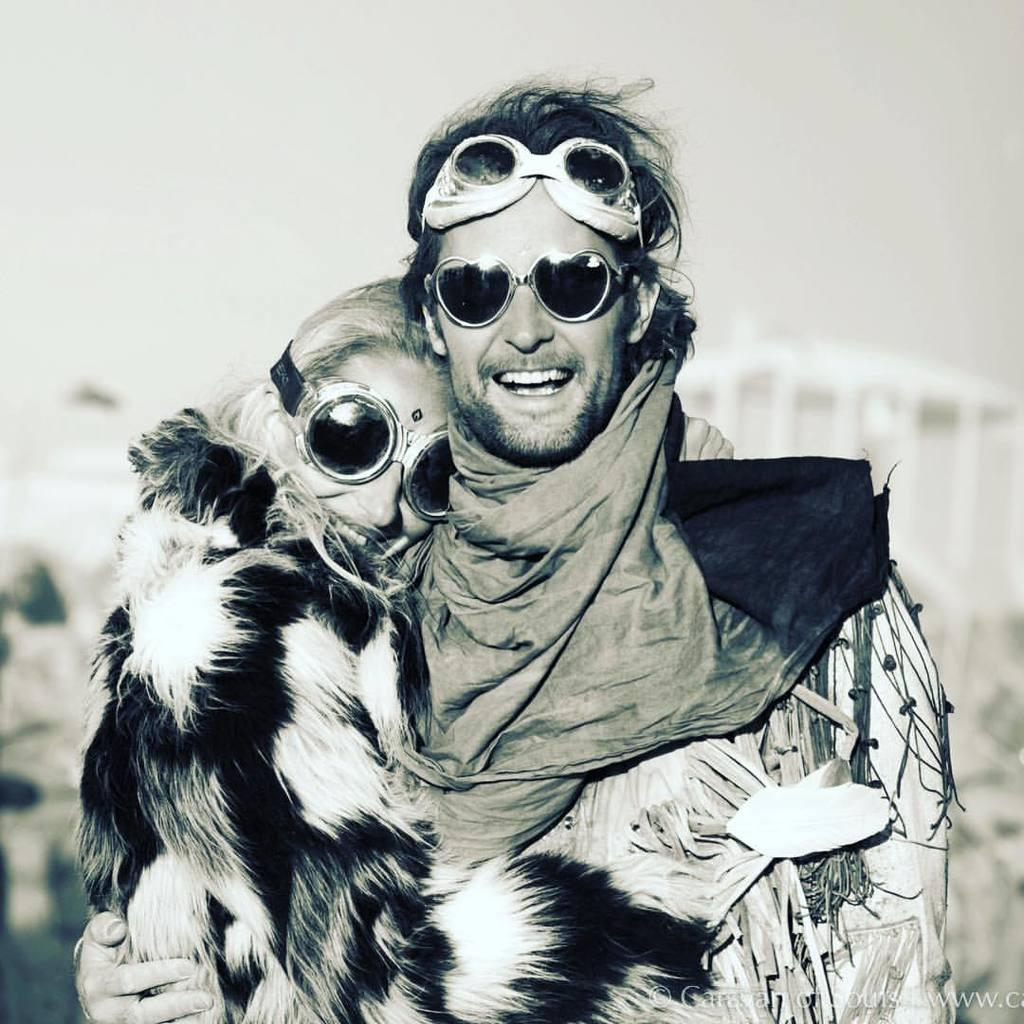Who is present in the image? There is a couple in the image. What are the couple doing in the image? The couple is posing for the camera. What expression do the couple have in the image? The couple is smiling. What type of cable can be seen hanging from the couple's pocket in the image? There is no cable visible in the image, nor is there any reference to a pocket. 